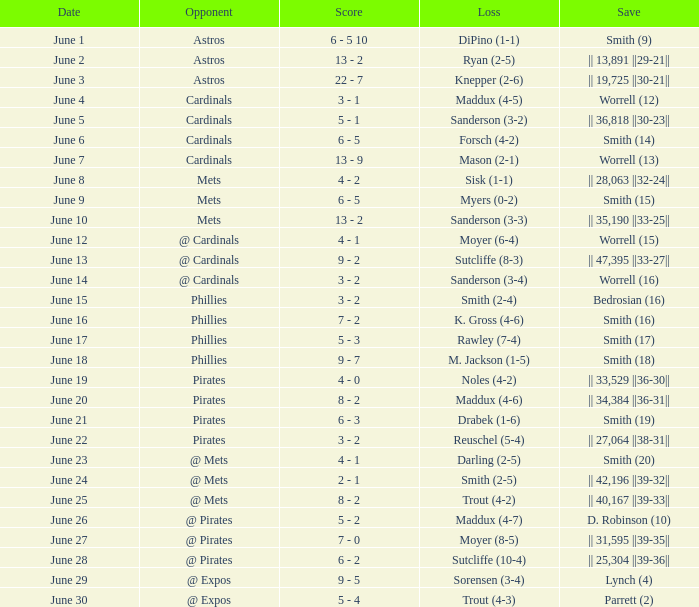When smith's loss was (2-4), what was the end score of the game? 3 - 2. 